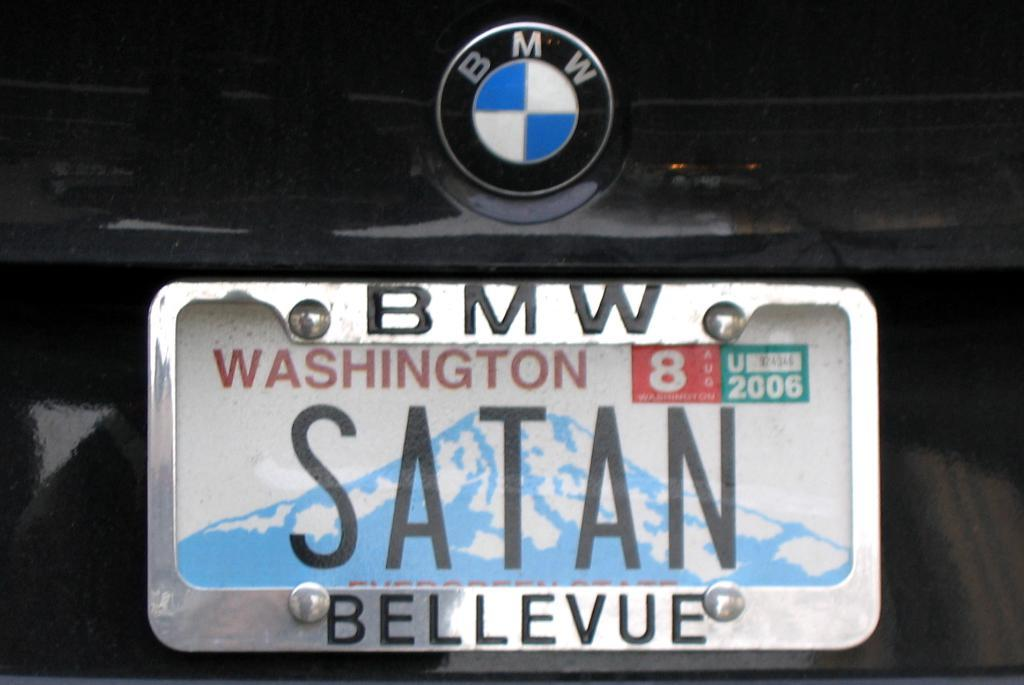<image>
Relay a brief, clear account of the picture shown. A BMW license plate with the plate number SATAN from Washington 